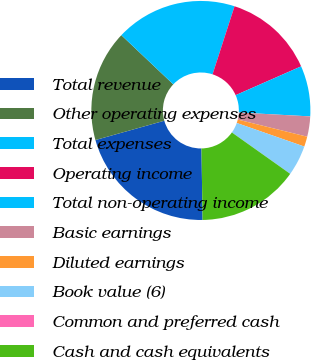<chart> <loc_0><loc_0><loc_500><loc_500><pie_chart><fcel>Total revenue<fcel>Other operating expenses<fcel>Total expenses<fcel>Operating income<fcel>Total non-operating income<fcel>Basic earnings<fcel>Diluted earnings<fcel>Book value (6)<fcel>Common and preferred cash<fcel>Cash and cash equivalents<nl><fcel>20.9%<fcel>16.42%<fcel>17.91%<fcel>13.43%<fcel>7.46%<fcel>2.99%<fcel>1.49%<fcel>4.48%<fcel>0.0%<fcel>14.93%<nl></chart> 